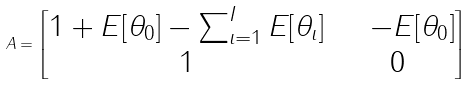<formula> <loc_0><loc_0><loc_500><loc_500>A = \begin{bmatrix} 1 + E [ \theta _ { 0 } ] - \sum _ { \iota = 1 } ^ { I } E [ \theta _ { \iota } ] & \quad - E [ \theta _ { 0 } ] \\ 1 & 0 \end{bmatrix}</formula> 